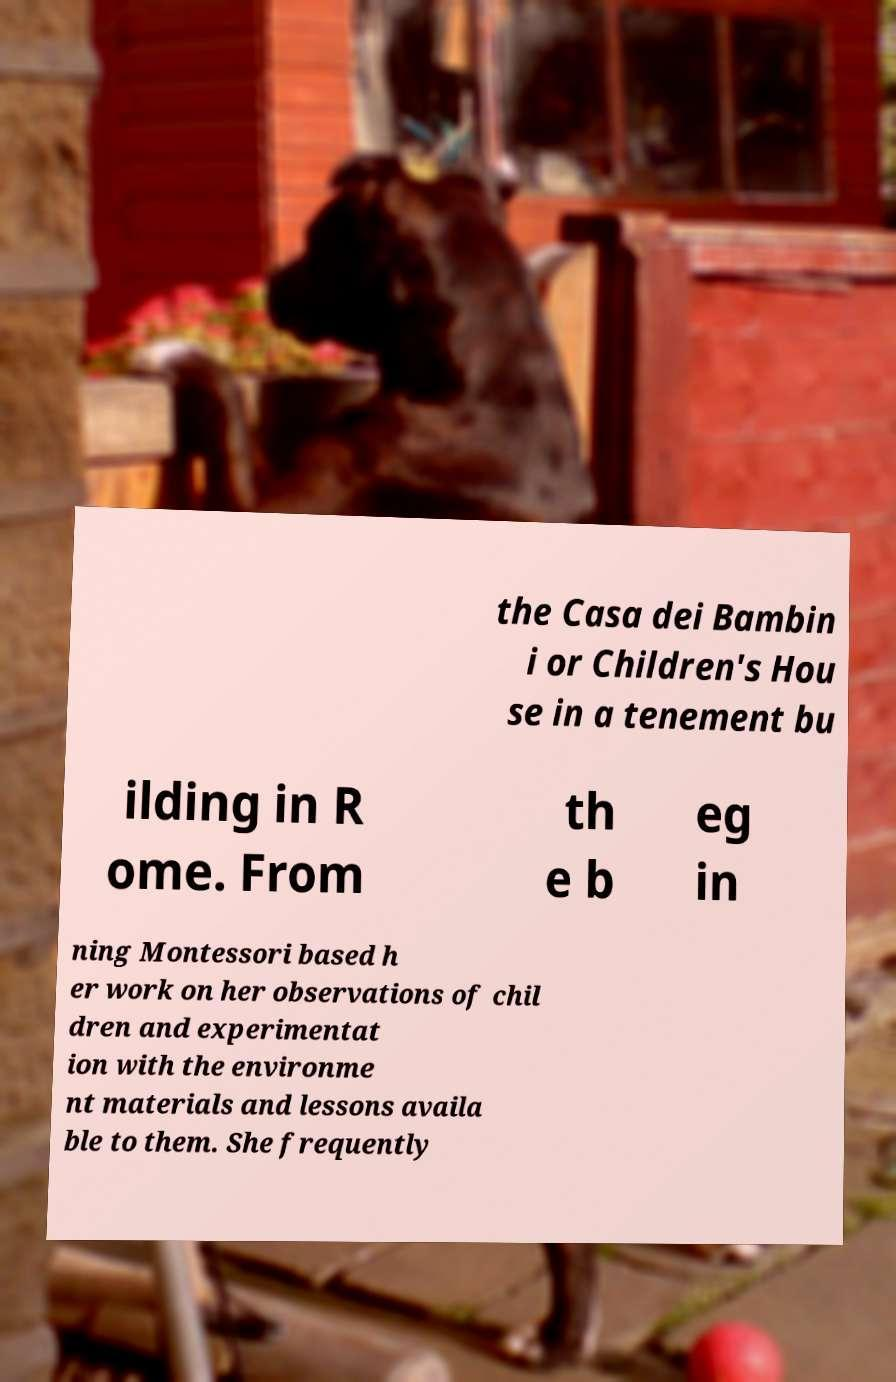Could you extract and type out the text from this image? the Casa dei Bambin i or Children's Hou se in a tenement bu ilding in R ome. From th e b eg in ning Montessori based h er work on her observations of chil dren and experimentat ion with the environme nt materials and lessons availa ble to them. She frequently 